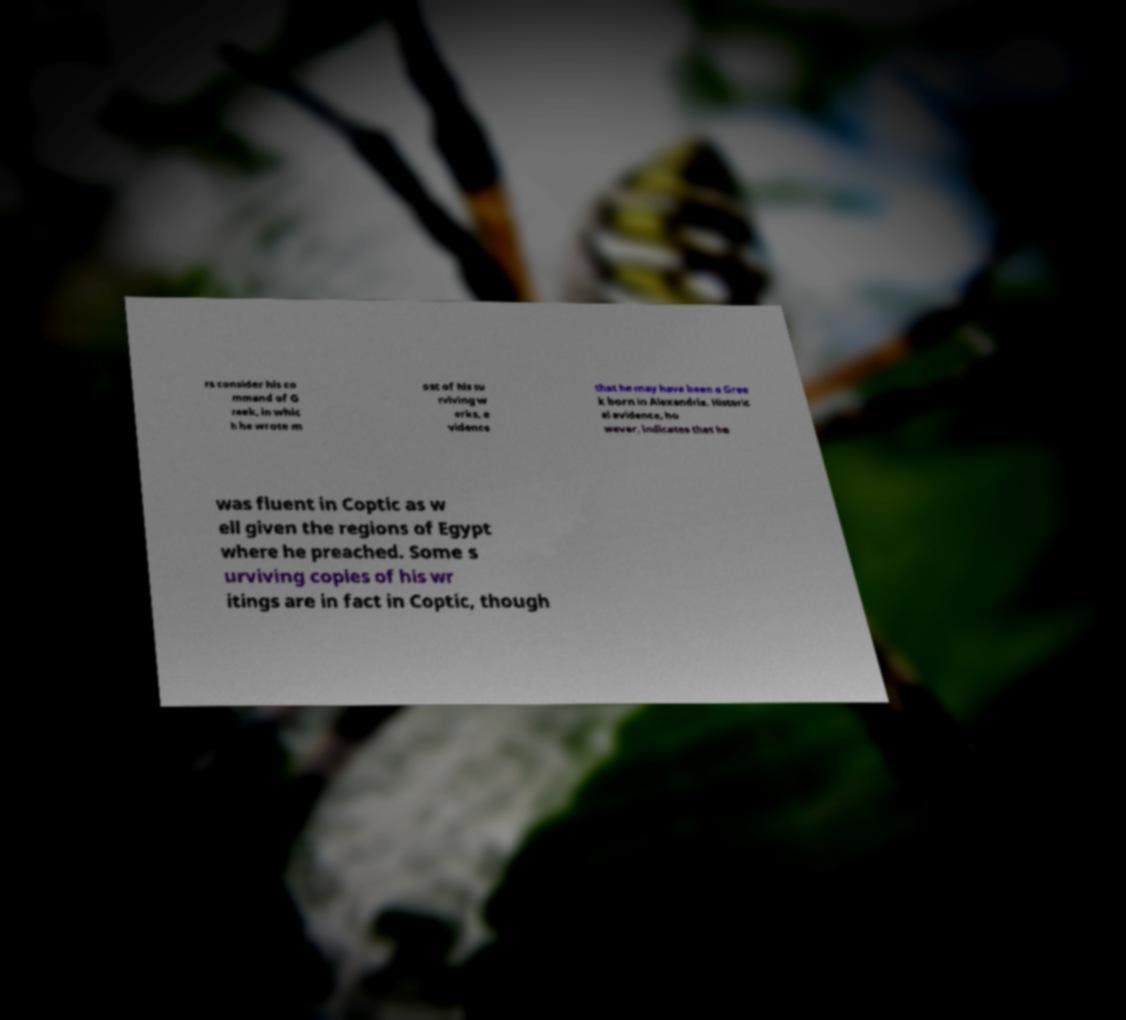I need the written content from this picture converted into text. Can you do that? rs consider his co mmand of G reek, in whic h he wrote m ost of his su rviving w orks, e vidence that he may have been a Gree k born in Alexandria. Historic al evidence, ho wever, indicates that he was fluent in Coptic as w ell given the regions of Egypt where he preached. Some s urviving copies of his wr itings are in fact in Coptic, though 